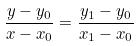<formula> <loc_0><loc_0><loc_500><loc_500>\frac { y - y _ { 0 } } { x - x _ { 0 } } = \frac { y _ { 1 } - y _ { 0 } } { x _ { 1 } - x _ { 0 } }</formula> 